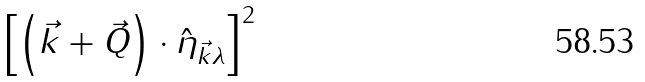<formula> <loc_0><loc_0><loc_500><loc_500>\left [ \left ( \vec { k } + \vec { Q } \right ) \cdot \hat { \eta } _ { \vec { k } \lambda } \right ] ^ { 2 }</formula> 